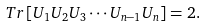Convert formula to latex. <formula><loc_0><loc_0><loc_500><loc_500>T r \left [ U _ { 1 } U _ { 2 } U _ { 3 } \cdots U _ { n - 1 } U _ { n } \right ] = 2 .</formula> 